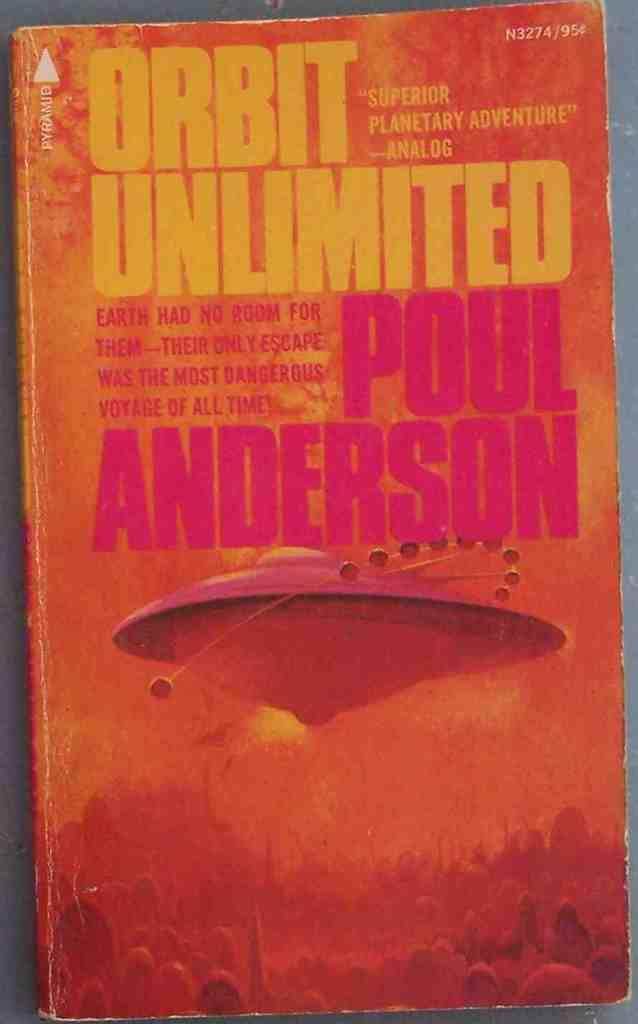Provide a one-sentence caption for the provided image. Analog called the book ORBIT UNLIMITED a "Superior Planetary Adventure". 